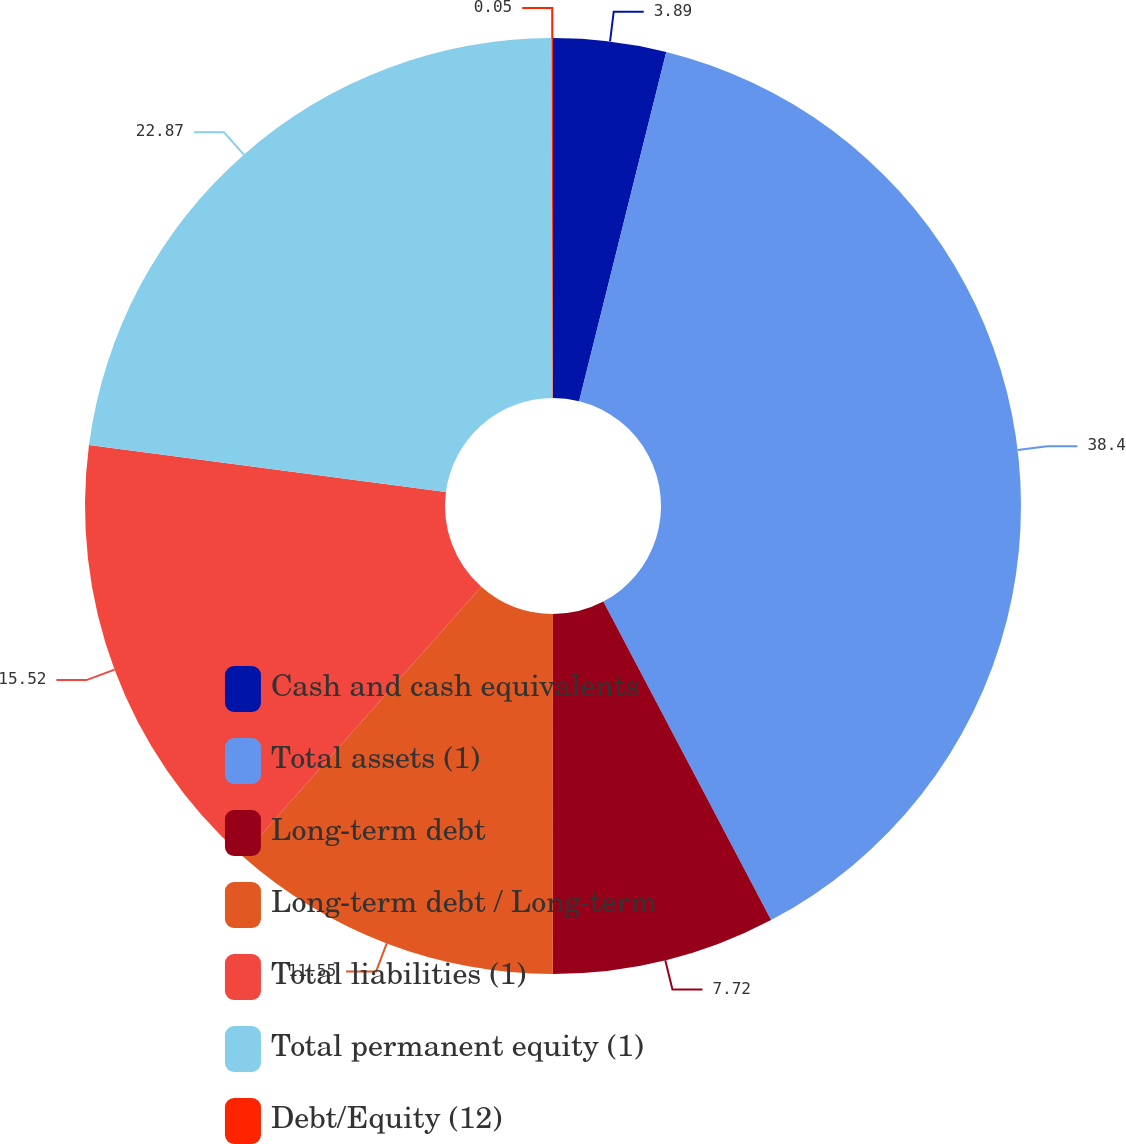Convert chart. <chart><loc_0><loc_0><loc_500><loc_500><pie_chart><fcel>Cash and cash equivalents<fcel>Total assets (1)<fcel>Long-term debt<fcel>Long-term debt / Long-term<fcel>Total liabilities (1)<fcel>Total permanent equity (1)<fcel>Debt/Equity (12)<nl><fcel>3.89%<fcel>38.39%<fcel>7.72%<fcel>11.55%<fcel>15.52%<fcel>22.87%<fcel>0.05%<nl></chart> 